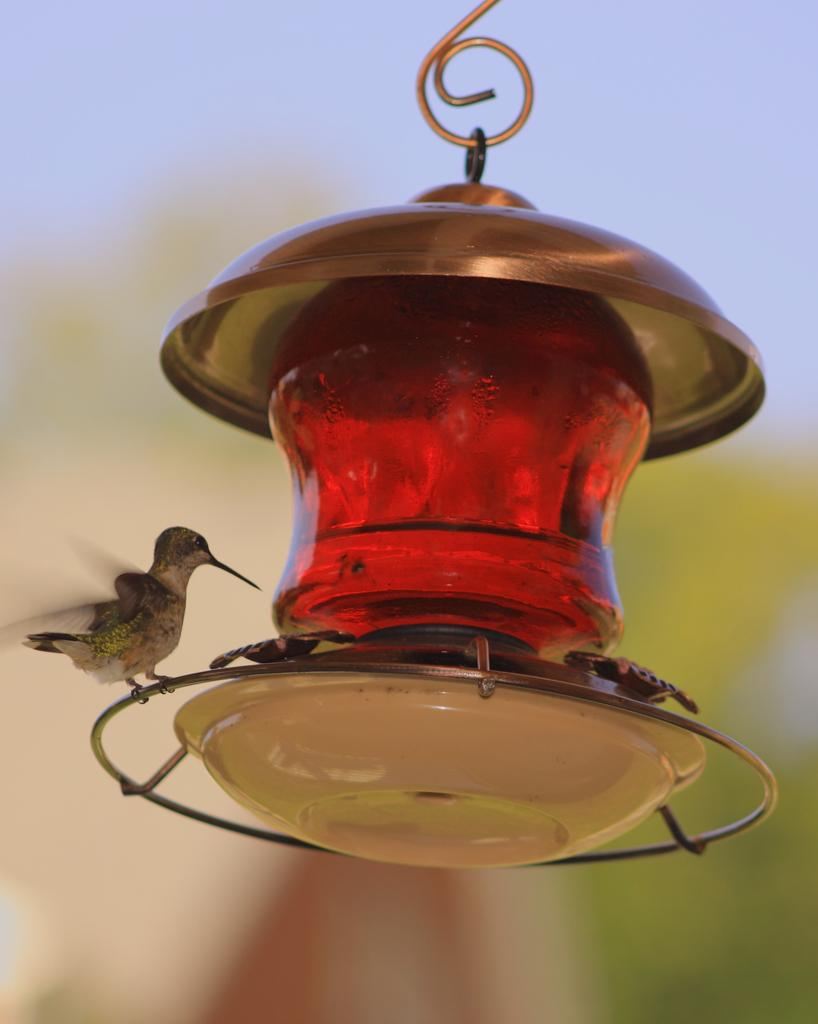What is on the lantern in the image? There is a bird on a lantern in the image. How would you describe the background of the image? The background is blurry. What part of the natural environment is visible in the image? The sky is visible in the background. What type of steel is the bird using to blow its mind in the image? There is no bird using steel to blow its mind in the image, as the image only features a bird on a lantern with a blurry background and visible sky. 